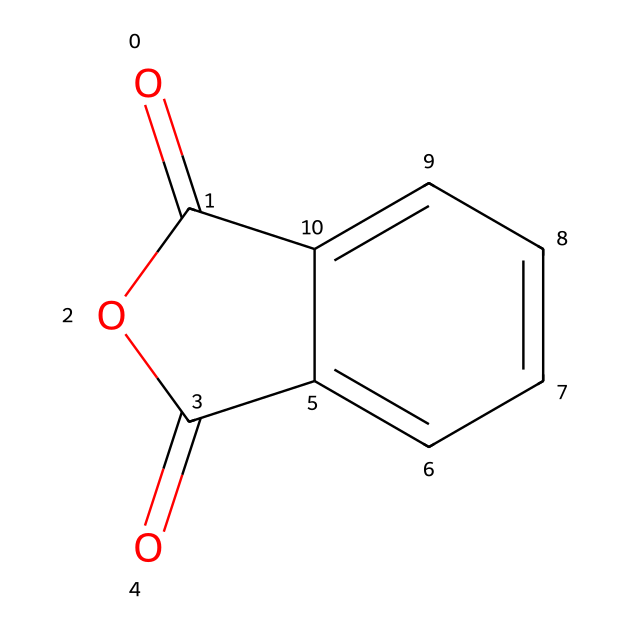What is the name of this chemical? This chemical's structure corresponds to the SMILES representation provided, which denotes phthalic anhydride. The presence of the anhydride functional group and the aromatic ring structure distinguishes it clearly as phthalic anhydride.
Answer: phthalic anhydride How many carbon atoms are in phthalic anhydride? By analyzing the SMILES structure, we identify each 'C' within the representation. The molecule contains 8 carbon atoms in total, counting both the aromatic carbons and those in the anhydride cycle.
Answer: 8 What type of functional group is present in phthalic anhydride? The structure shows two carbonyl groups (C=O) attached to an oxygen atom in the anhydride formation. This configuration indicates that phthalic anhydride contains an anhydride functional group.
Answer: anhydride How many oxygen atoms are present in phthalic anhydride? The molecule contains 3 oxygen atoms, which can be counted from the SMILES representation, including those in the carbonyl groups and the anhydride linkage.
Answer: 3 Does phthalic anhydride contain any nitrogen atoms? Analyzing the SMILES, we find that there are no nitrogen atoms present in the structure since none are indicated by 'N' in the formula.
Answer: no What is the molecular formula of phthalic anhydride? The molecular formula can be derived from the count of each atom in the SMILES representation: 8 carbons, 4 hydrogens, and 3 oxygens, giving C8H4O3 as the molecular formula.
Answer: C8H4O3 What properties of phthalic anhydride make it useful in hair dye fixatives? Phthalic anhydride's reactivity due to its anhydride functionality allows it to form stable bonds with other ingredients in hair dyes, which is crucial for the durability and longevity of the color fixatives.
Answer: reactivity 